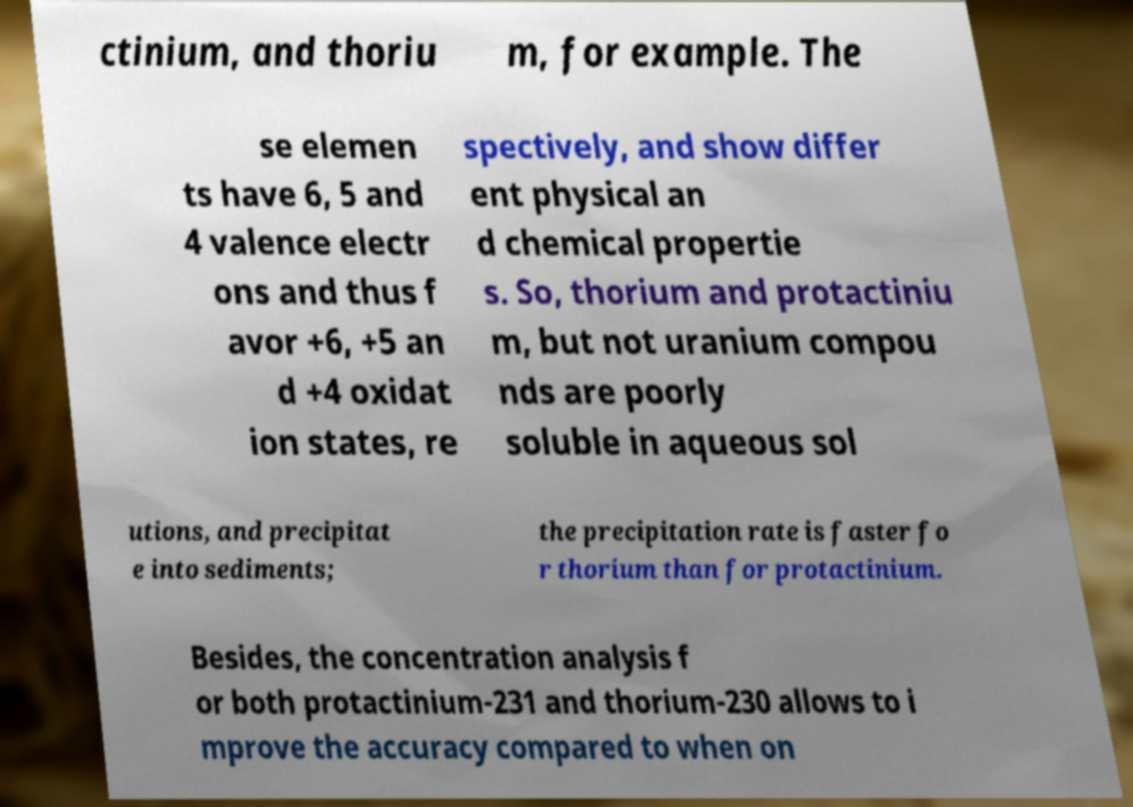Could you extract and type out the text from this image? ctinium, and thoriu m, for example. The se elemen ts have 6, 5 and 4 valence electr ons and thus f avor +6, +5 an d +4 oxidat ion states, re spectively, and show differ ent physical an d chemical propertie s. So, thorium and protactiniu m, but not uranium compou nds are poorly soluble in aqueous sol utions, and precipitat e into sediments; the precipitation rate is faster fo r thorium than for protactinium. Besides, the concentration analysis f or both protactinium-231 and thorium-230 allows to i mprove the accuracy compared to when on 